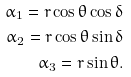Convert formula to latex. <formula><loc_0><loc_0><loc_500><loc_500>\alpha _ { 1 } = r \cos \theta \cos \delta \\ \alpha _ { 2 } = r \cos \theta \sin \delta \\ \alpha _ { 3 } = r \sin \theta .</formula> 